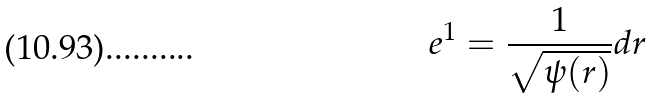<formula> <loc_0><loc_0><loc_500><loc_500>e ^ { 1 } = \frac { 1 } { \sqrt { \psi ( r ) } } d r</formula> 